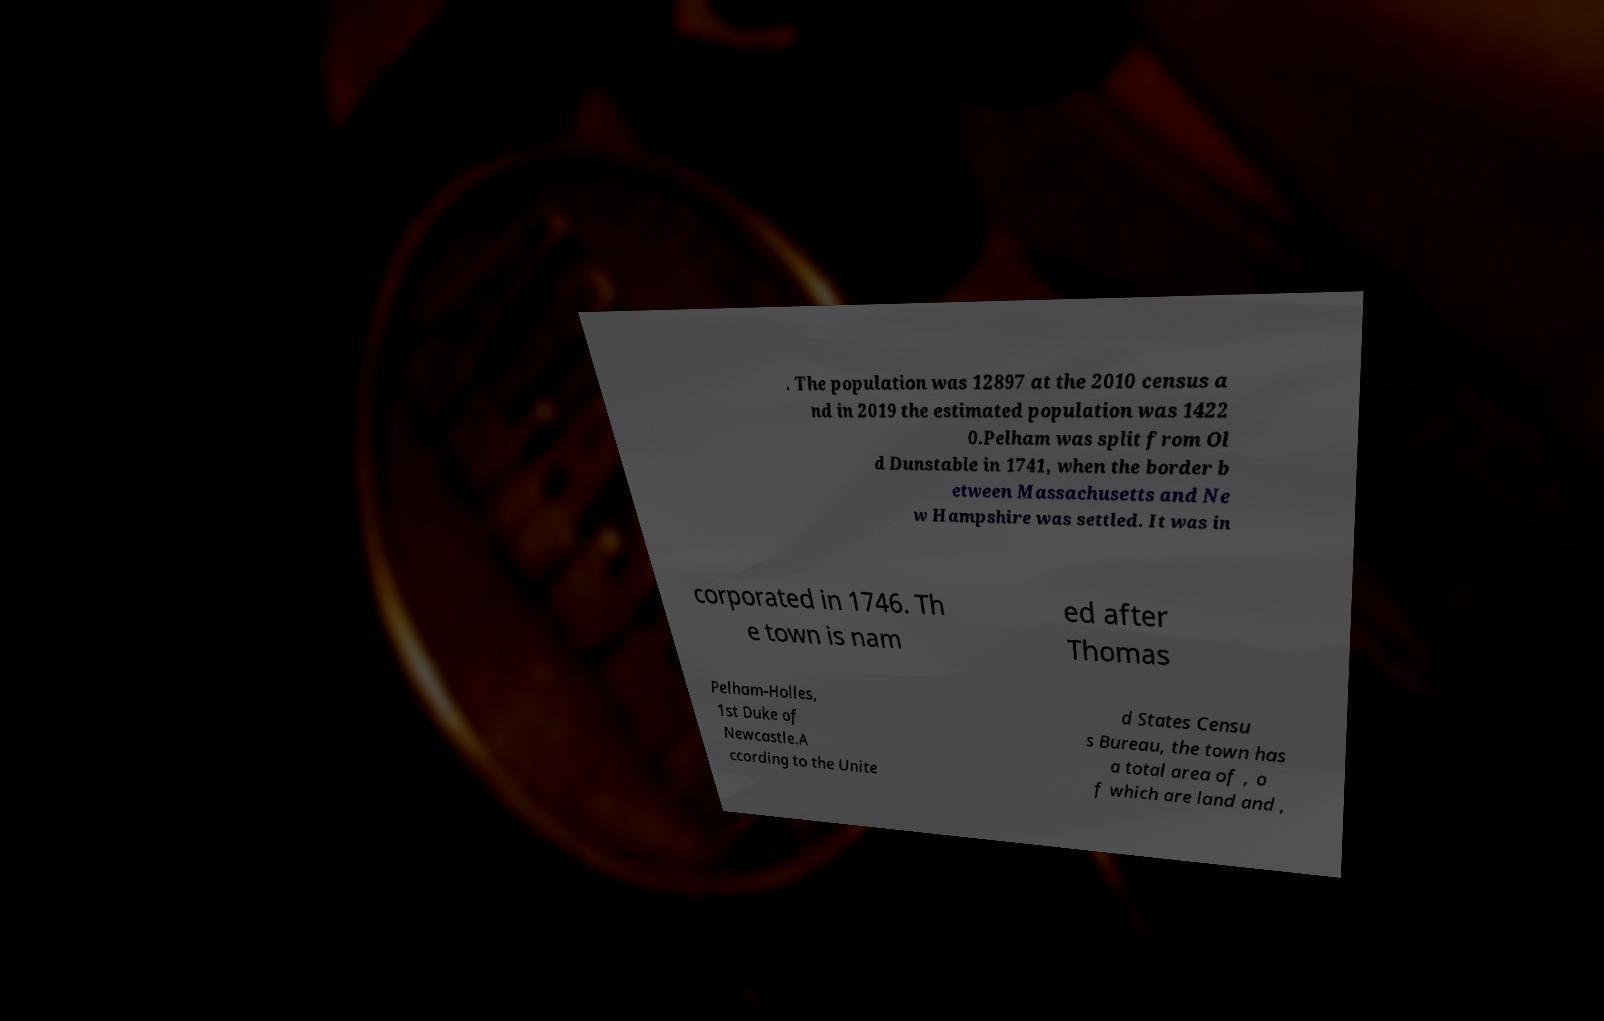I need the written content from this picture converted into text. Can you do that? . The population was 12897 at the 2010 census a nd in 2019 the estimated population was 1422 0.Pelham was split from Ol d Dunstable in 1741, when the border b etween Massachusetts and Ne w Hampshire was settled. It was in corporated in 1746. Th e town is nam ed after Thomas Pelham-Holles, 1st Duke of Newcastle.A ccording to the Unite d States Censu s Bureau, the town has a total area of , o f which are land and , 